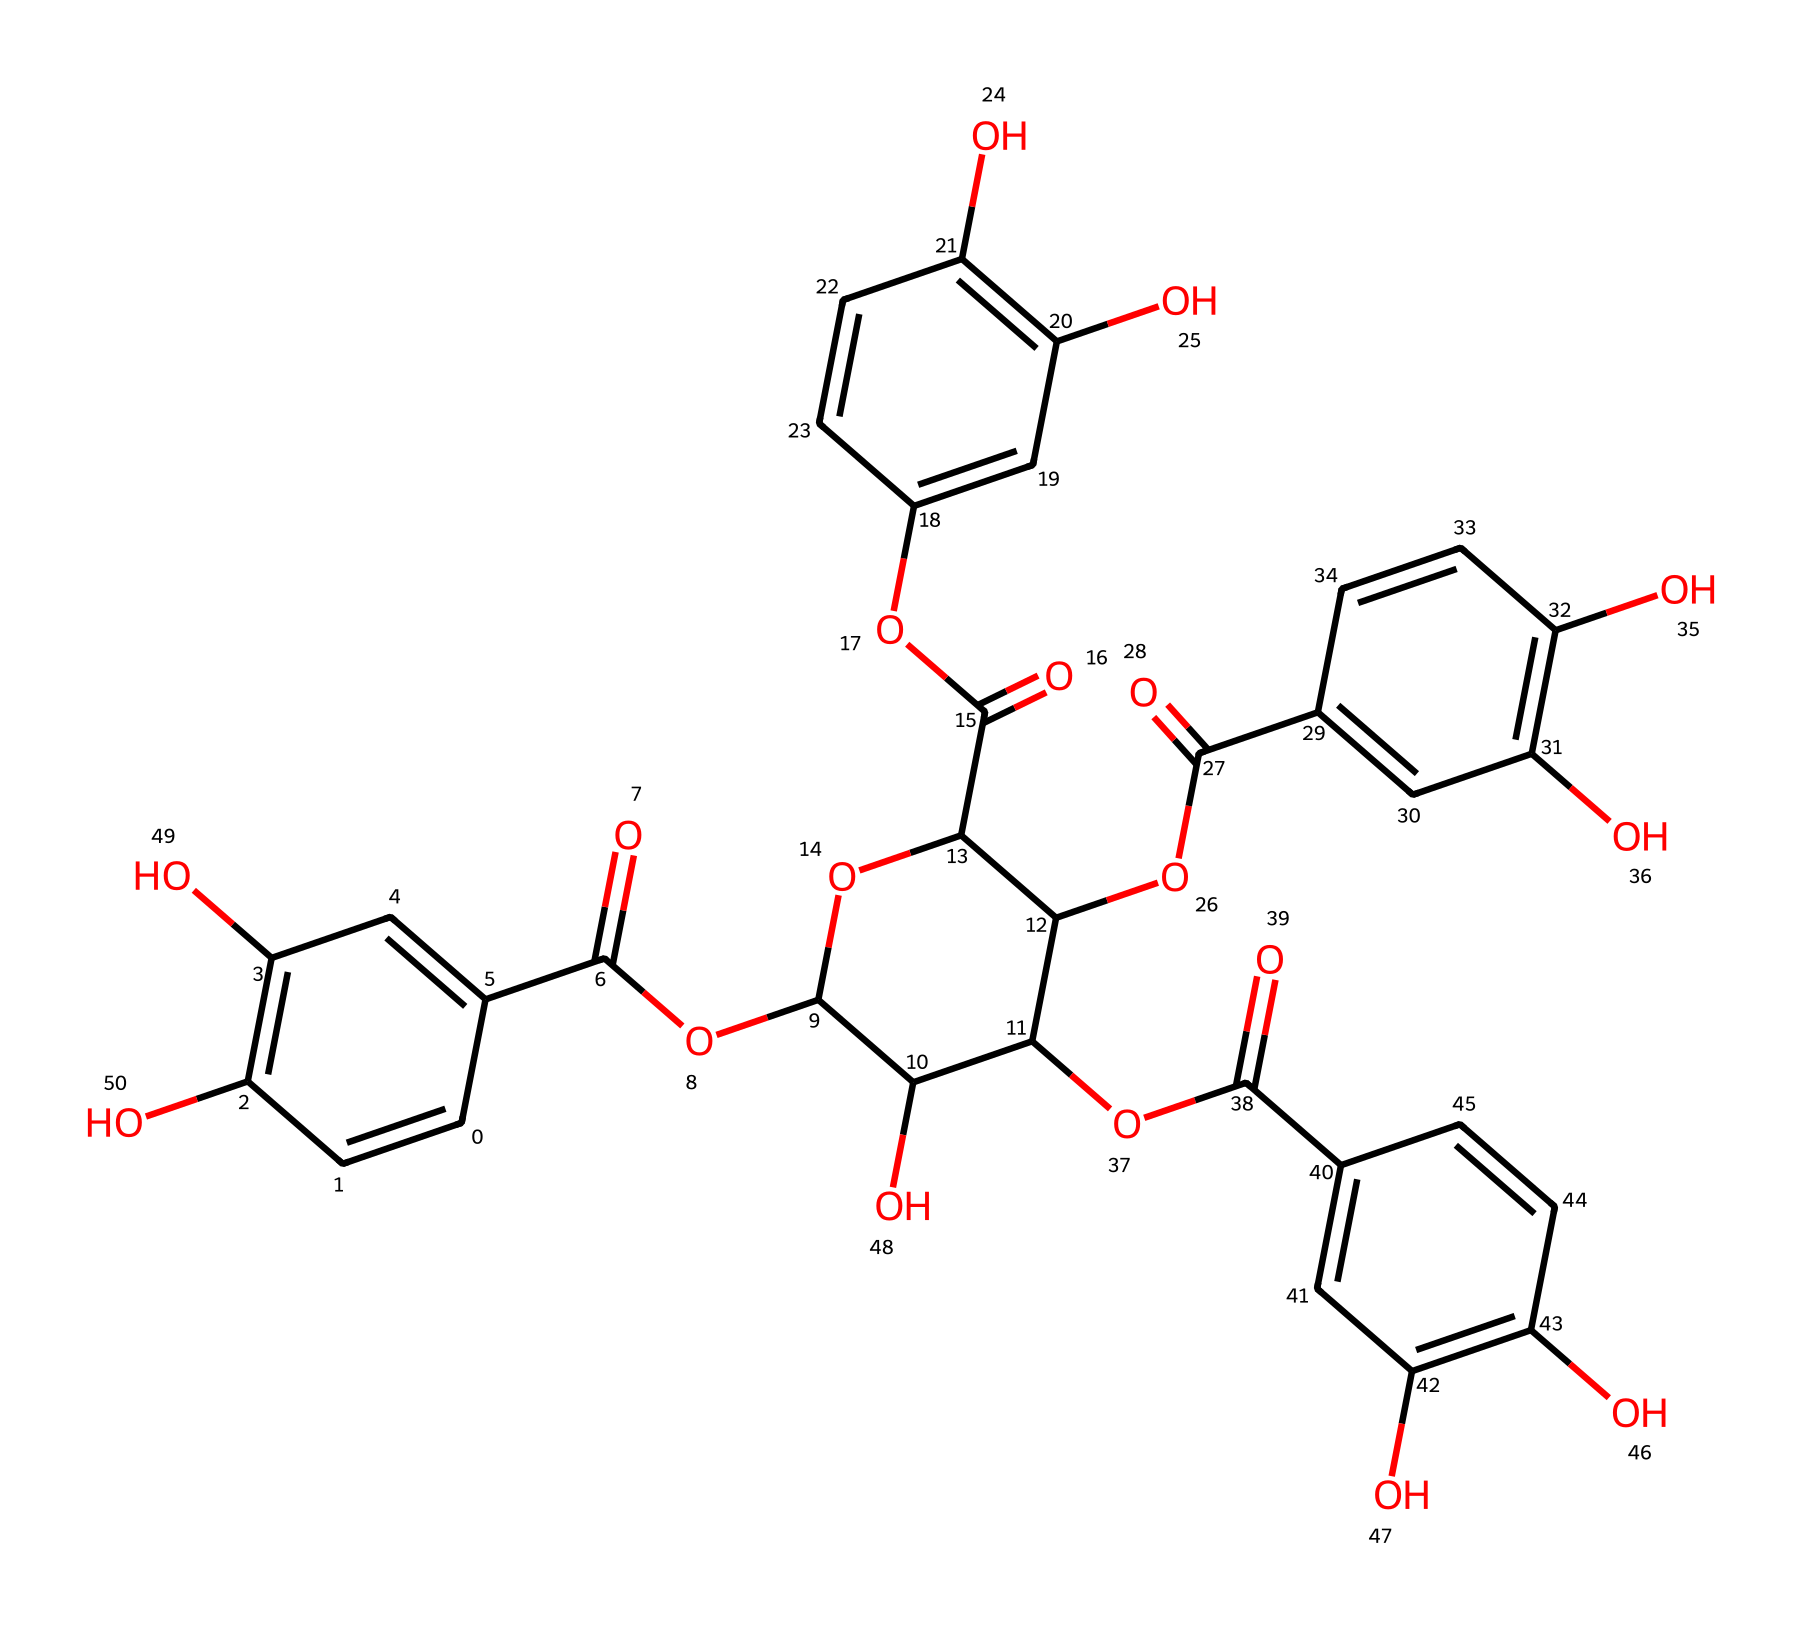What is the primary functional group present in this chemical? The visual representation of the chemical shows multiple hydroxyl (-OH) groups attached to the aromatic rings, indicating that hydroxyl is the primary functional group.
Answer: hydroxyl How many benzene rings are present in this chemical structure? By examining the structure, we can identify four distinct aromatic (benzene) rings. Each ring is enclosed and has alternating double bonds characteristic of benzene.
Answer: four What type of chemical is this compound mainly classified as? The structure indicates multiple phenolic groups and a complex arrangement, which categorizes it mainly as a flavonoid. Flavonoids are a subtype of phenolic compounds, typically found in plants.
Answer: flavonoid How many carboxyl groups (–COOH) does this chemical contain? Upon visual inspection of the chemical structure, it is clear that there are three carboxyl groups evident, each contributing to its acidic properties.
Answer: three Which part of this chemical is responsible for its astringent properties? The presence of the hydroxyl groups on the aromatic rings suggests that these contribute to the astringent properties, as these groups can interact with proteins and precipitate them.
Answer: hydroxyl groups What is the molecular feature that helps this chemical bind to fabric during the dyeing process? The multiple hydroxyl groups facilitate hydrogen bonding, allowing the compound to effectively bind to fabric fibers during the dyeing process.
Answer: hydrogen bonding 